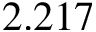Convert formula to latex. <formula><loc_0><loc_0><loc_500><loc_500>2 . 2 1 7</formula> 